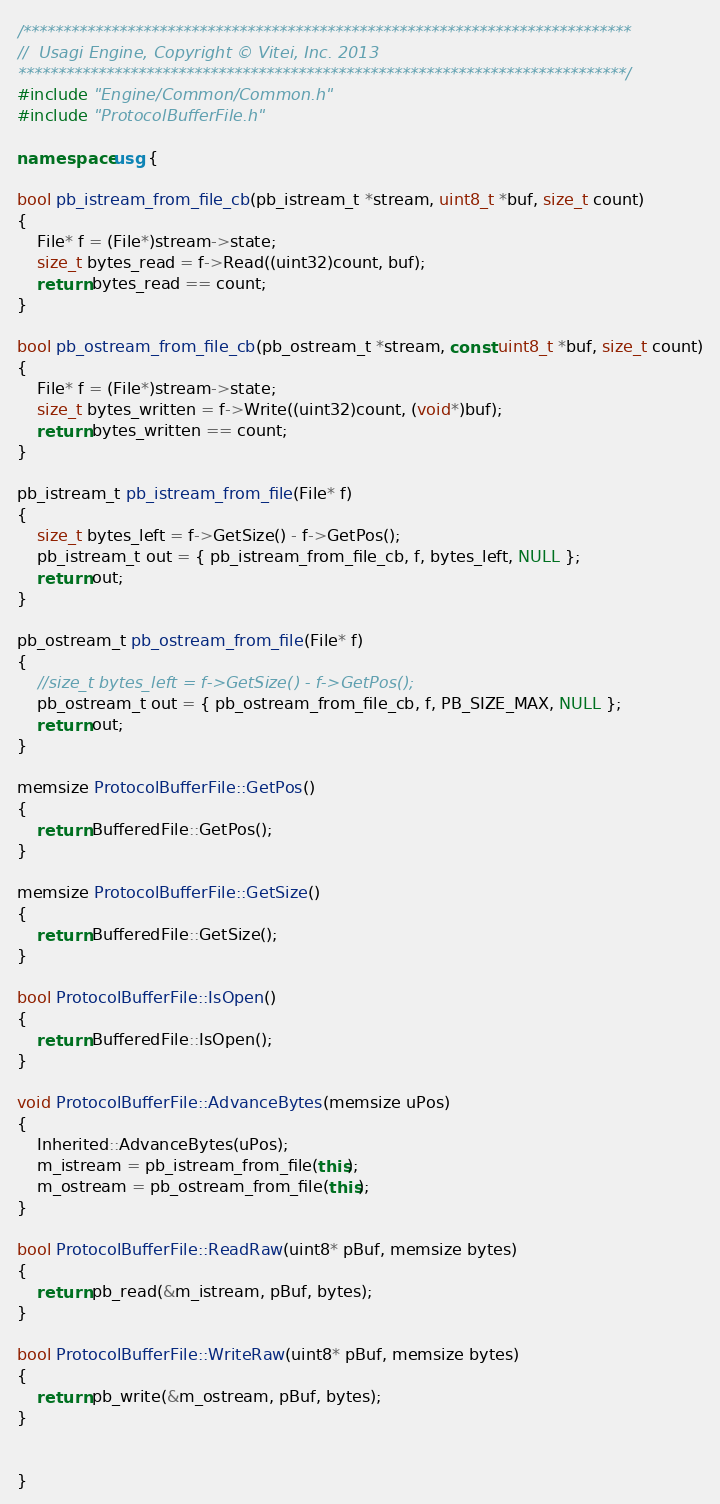Convert code to text. <code><loc_0><loc_0><loc_500><loc_500><_C++_>/****************************************************************************
//	Usagi Engine, Copyright © Vitei, Inc. 2013
****************************************************************************/
#include "Engine/Common/Common.h"
#include "ProtocolBufferFile.h"

namespace usg {

bool pb_istream_from_file_cb(pb_istream_t *stream, uint8_t *buf, size_t count)
{
	File* f = (File*)stream->state;
	size_t bytes_read = f->Read((uint32)count, buf);
	return bytes_read == count;
}

bool pb_ostream_from_file_cb(pb_ostream_t *stream, const uint8_t *buf, size_t count)
{
	File* f = (File*)stream->state;
	size_t bytes_written = f->Write((uint32)count, (void*)buf);
	return bytes_written == count;
}

pb_istream_t pb_istream_from_file(File* f)
{
	size_t bytes_left = f->GetSize() - f->GetPos();
	pb_istream_t out = { pb_istream_from_file_cb, f, bytes_left, NULL };
	return out;
}

pb_ostream_t pb_ostream_from_file(File* f)
{
	//size_t bytes_left = f->GetSize() - f->GetPos();
	pb_ostream_t out = { pb_ostream_from_file_cb, f, PB_SIZE_MAX, NULL };
	return out;
}

memsize ProtocolBufferFile::GetPos()
{
	return BufferedFile::GetPos();
}

memsize ProtocolBufferFile::GetSize()
{
	return BufferedFile::GetSize();
}

bool ProtocolBufferFile::IsOpen()
{
	return BufferedFile::IsOpen();
}

void ProtocolBufferFile::AdvanceBytes(memsize uPos)
{ 
	Inherited::AdvanceBytes(uPos);
	m_istream = pb_istream_from_file(this);
	m_ostream = pb_ostream_from_file(this);
}

bool ProtocolBufferFile::ReadRaw(uint8* pBuf, memsize bytes)
{
	return pb_read(&m_istream, pBuf, bytes);
}

bool ProtocolBufferFile::WriteRaw(uint8* pBuf, memsize bytes)
{
	return pb_write(&m_ostream, pBuf, bytes);
}


}
</code> 